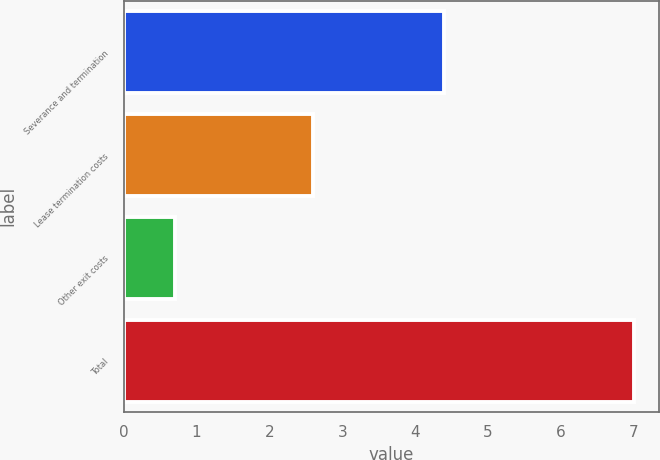<chart> <loc_0><loc_0><loc_500><loc_500><bar_chart><fcel>Severance and termination<fcel>Lease termination costs<fcel>Other exit costs<fcel>Total<nl><fcel>4.4<fcel>2.6<fcel>0.7<fcel>7<nl></chart> 